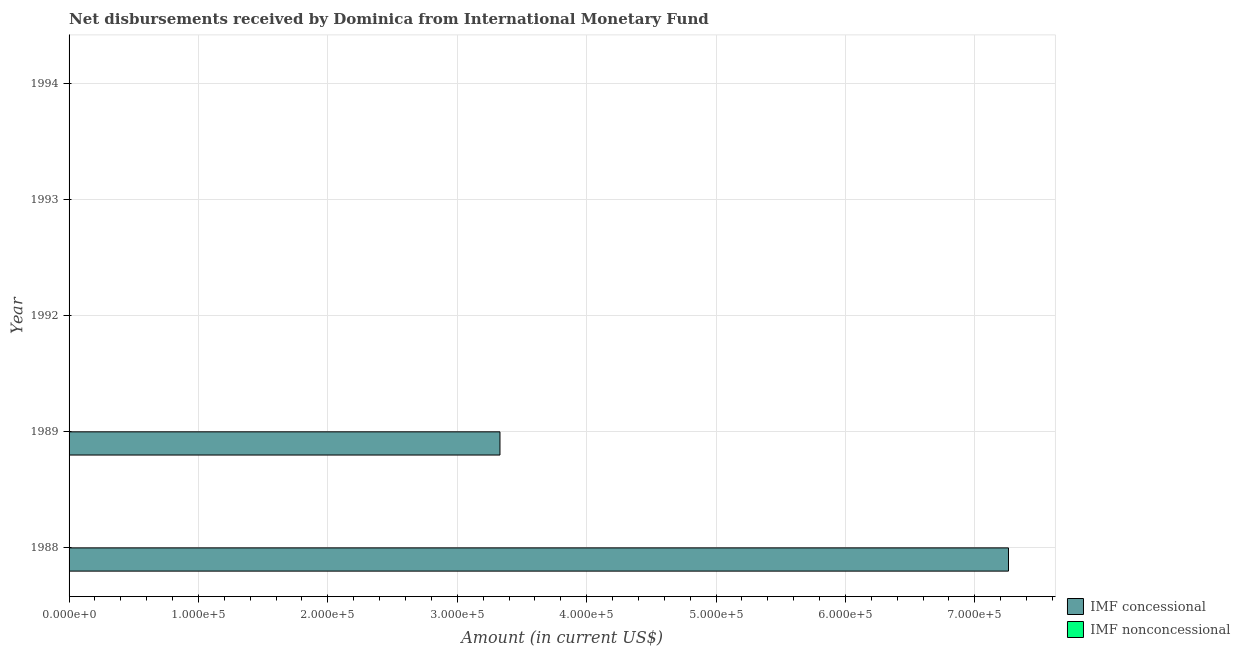What is the label of the 3rd group of bars from the top?
Your answer should be very brief. 1992. Across all years, what is the maximum net concessional disbursements from imf?
Your answer should be compact. 7.26e+05. Across all years, what is the minimum net non concessional disbursements from imf?
Your answer should be very brief. 0. In which year was the net concessional disbursements from imf maximum?
Offer a terse response. 1988. What is the total net concessional disbursements from imf in the graph?
Provide a short and direct response. 1.06e+06. What is the difference between the net concessional disbursements from imf in 1992 and the net non concessional disbursements from imf in 1994?
Make the answer very short. 0. What is the average net non concessional disbursements from imf per year?
Your answer should be compact. 0. What is the ratio of the net concessional disbursements from imf in 1988 to that in 1989?
Ensure brevity in your answer.  2.18. What is the difference between the highest and the lowest net concessional disbursements from imf?
Keep it short and to the point. 7.26e+05. How many bars are there?
Offer a terse response. 2. Are all the bars in the graph horizontal?
Your answer should be compact. Yes. How many years are there in the graph?
Your answer should be compact. 5. What is the difference between two consecutive major ticks on the X-axis?
Keep it short and to the point. 1.00e+05. How are the legend labels stacked?
Your response must be concise. Vertical. What is the title of the graph?
Make the answer very short. Net disbursements received by Dominica from International Monetary Fund. Does "Methane" appear as one of the legend labels in the graph?
Give a very brief answer. No. What is the label or title of the X-axis?
Your answer should be very brief. Amount (in current US$). What is the label or title of the Y-axis?
Give a very brief answer. Year. What is the Amount (in current US$) of IMF concessional in 1988?
Offer a terse response. 7.26e+05. What is the Amount (in current US$) of IMF concessional in 1989?
Offer a very short reply. 3.33e+05. What is the Amount (in current US$) of IMF nonconcessional in 1993?
Provide a succinct answer. 0. What is the Amount (in current US$) of IMF concessional in 1994?
Provide a short and direct response. 0. What is the Amount (in current US$) in IMF nonconcessional in 1994?
Keep it short and to the point. 0. Across all years, what is the maximum Amount (in current US$) in IMF concessional?
Give a very brief answer. 7.26e+05. Across all years, what is the minimum Amount (in current US$) of IMF concessional?
Ensure brevity in your answer.  0. What is the total Amount (in current US$) of IMF concessional in the graph?
Give a very brief answer. 1.06e+06. What is the total Amount (in current US$) in IMF nonconcessional in the graph?
Your response must be concise. 0. What is the difference between the Amount (in current US$) of IMF concessional in 1988 and that in 1989?
Give a very brief answer. 3.93e+05. What is the average Amount (in current US$) in IMF concessional per year?
Provide a short and direct response. 2.12e+05. What is the ratio of the Amount (in current US$) of IMF concessional in 1988 to that in 1989?
Make the answer very short. 2.18. What is the difference between the highest and the lowest Amount (in current US$) in IMF concessional?
Offer a very short reply. 7.26e+05. 